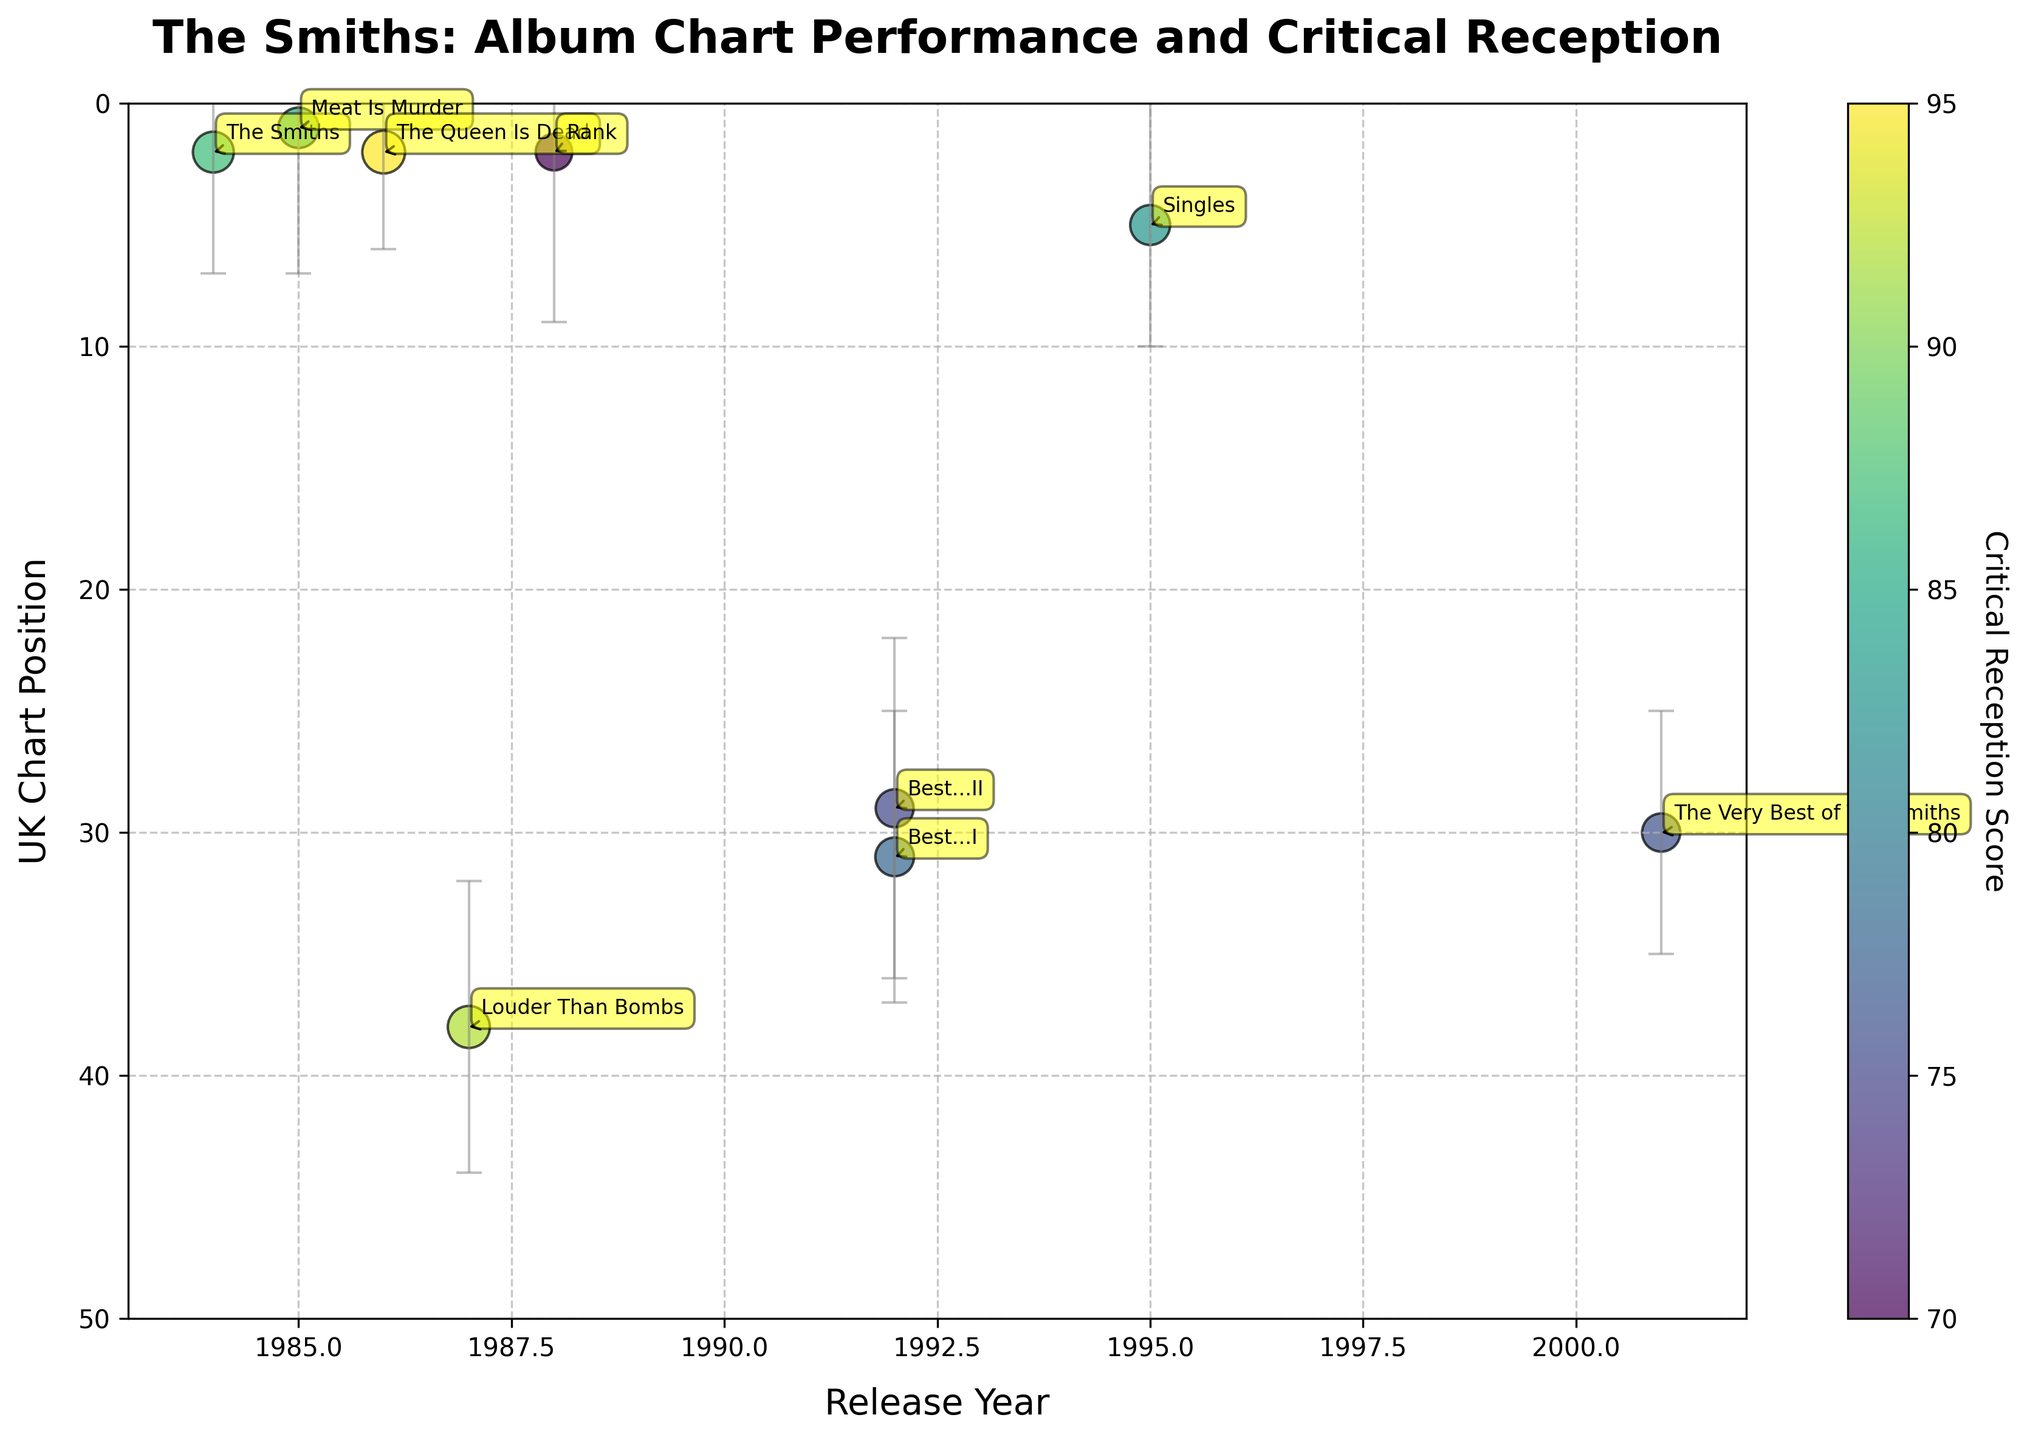How many albums by The Smiths are shown in the figure? Count the number of unique data points in the figure corresponding to each album title.
Answer: 9 Which album has the highest UK chart position? Look for the album with the lowest y-value in the UK chart position axis, as the axis is inverted.
Answer: "Meat Is Murder" What decade has the most albums represented in the figure? Count the number of albums released in each decade as indicated by the years on the x-axis.
Answer: 1980s Which album has the highest critical reception score? Identify the album represented by the largest dot and the greatest value on the color scale.
Answer: "The Queen Is Dead" What is the average critical reception score of the albums released in the 1990s? Sum the critical reception scores of albums released in the 1990s and divide by the number of those albums: (78 + 75 + 83) / 3
Answer: 78.7 What is the difference in UK chart position between "The Queen Is Dead" and "Rank"? Subtract the UK chart position of "The Queen Is Dead" from that of "Rank". Since the UK chart position axis is inverted, it's 2 - 2 = 0.
Answer: 0 Which album has the largest standard deviation in its chart position? Identify the album with the longest gray error bar indicating the standard deviation.
Answer: "Rank" How does the UK chart position of "Louder Than Bombs" compare to "The Smiths"? Compare the y-values (inverted) of both albums' chart positions in the UK. "Louder Than Bombs" has a higher position (closer to 50) than "The Smiths".
Answer: "Louder Than Bombs" is lower (less position) Which album released after 2000 is represented in the figure, and what is its critical reception score? Look at the x-axis for years after 2000 and find the associated data point. The critical reception score corresponds to the color of the dot.
Answer: "The Very Best of The Smiths," 76 What is the overall trend in critical reception scores over time? Observing the scatter plot, note the change in dot size and color gradient from earlier to later years.
Answer: Generally consistent with some fluctuations, highest in the mid-80s 